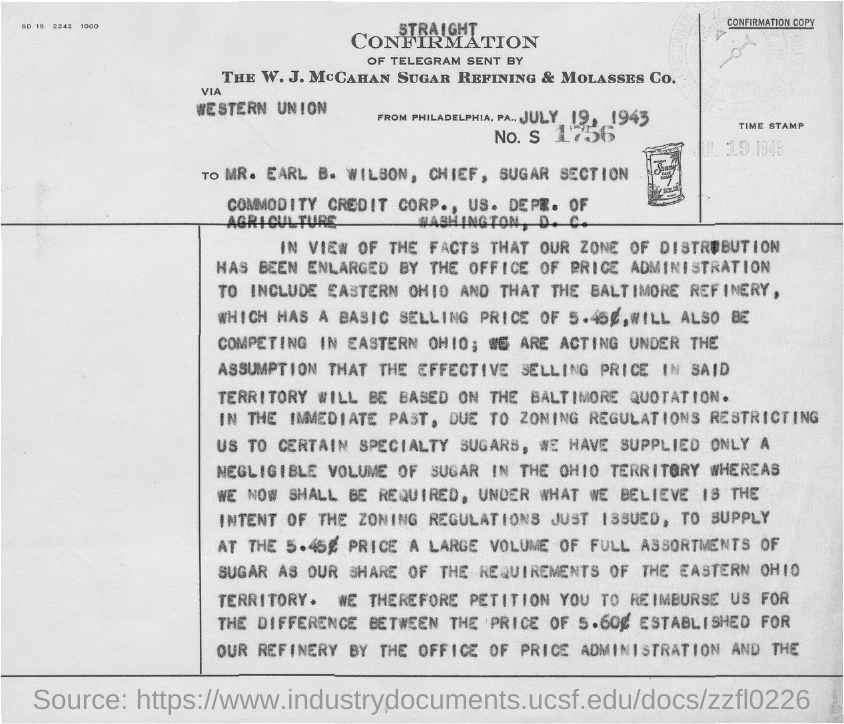Draw attention to some important aspects in this diagram. The number 1756 is mentioned in the given form. The time stamp mentioned in the given form is July 19, 1943. 